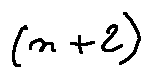<formula> <loc_0><loc_0><loc_500><loc_500>( n + 2 )</formula> 